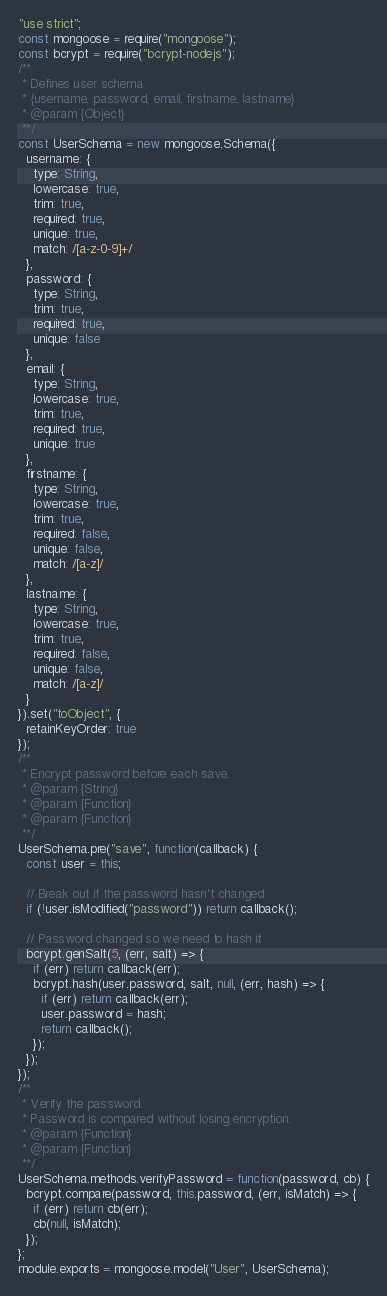Convert code to text. <code><loc_0><loc_0><loc_500><loc_500><_JavaScript_>"use strict";
const mongoose = require("mongoose");
const bcrypt = require("bcrypt-nodejs");
/**
 * Defines user schema
 * {username, password, email, firstname, lastname}
 * @param {Object}
 **/
const UserSchema = new mongoose.Schema({
  username: {
    type: String,
    lowercase: true,
    trim: true,
    required: true,
    unique: true,
    match: /[a-z-0-9]+/
  },
  password: {
    type: String,
    trim: true,
    required: true,
    unique: false
  },
  email: {
    type: String,
    lowercase: true,
    trim: true,
    required: true,
    unique: true
  },
  firstname: {
    type: String,
    lowercase: true,
    trim: true,
    required: false,
    unique: false,
    match: /[a-z]/
  },
  lastname: {
    type: String,
    lowercase: true,
    trim: true,
    required: false,
    unique: false,
    match: /[a-z]/
  }
}).set("toObject", {
  retainKeyOrder: true
});
/**
 * Encrypt password before each save.
 * @param {String}
 * @param {Function}
 * @param {Function}
 **/
UserSchema.pre("save", function(callback) {
  const user = this;

  // Break out if the password hasn't changed
  if (!user.isModified("password")) return callback();

  // Password changed so we need to hash it
  bcrypt.genSalt(5, (err, salt) => {
    if (err) return callback(err);
    bcrypt.hash(user.password, salt, null, (err, hash) => {
      if (err) return callback(err);
      user.password = hash;
      return callback();
    });
  });
});
/**
 * Verify the password.
 * Password is compared without losing encryption.
 * @param {Function}
 * @param {Function}
 **/
UserSchema.methods.verifyPassword = function(password, cb) {
  bcrypt.compare(password, this.password, (err, isMatch) => {
    if (err) return cb(err);
    cb(null, isMatch);
  });
};
module.exports = mongoose.model("User", UserSchema);
</code> 